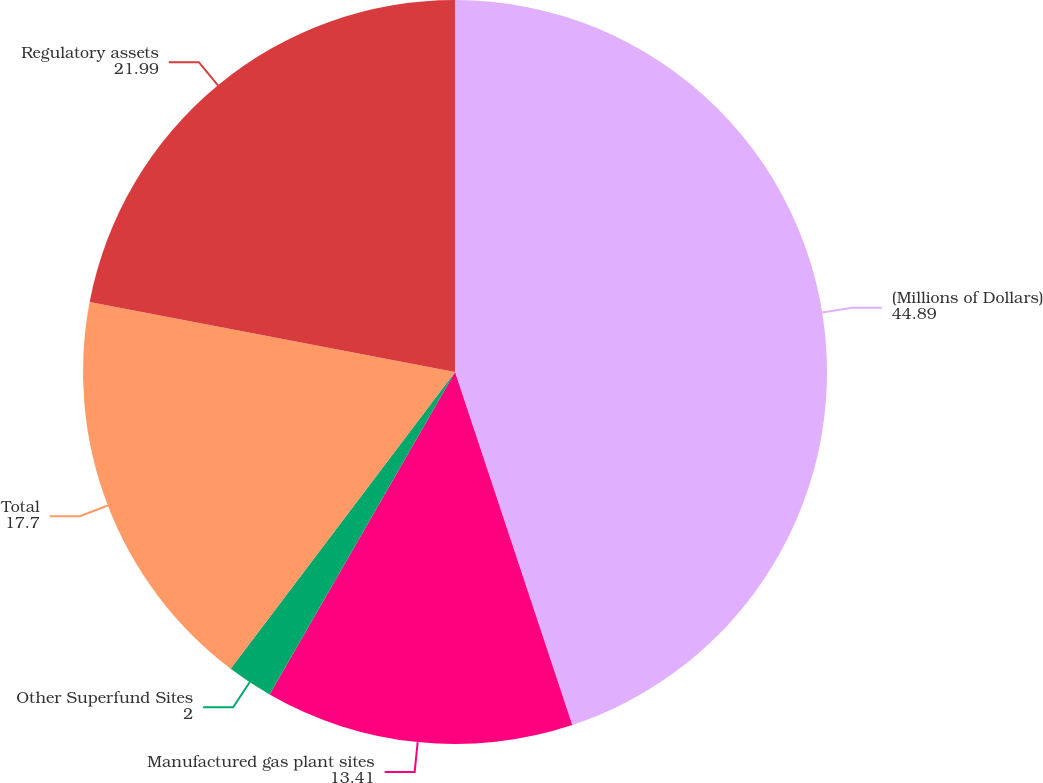Convert chart. <chart><loc_0><loc_0><loc_500><loc_500><pie_chart><fcel>(Millions of Dollars)<fcel>Manufactured gas plant sites<fcel>Other Superfund Sites<fcel>Total<fcel>Regulatory assets<nl><fcel>44.89%<fcel>13.41%<fcel>2.0%<fcel>17.7%<fcel>21.99%<nl></chart> 